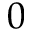<formula> <loc_0><loc_0><loc_500><loc_500>0</formula> 